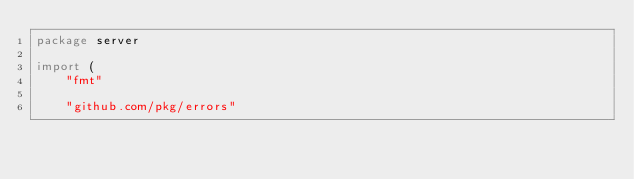Convert code to text. <code><loc_0><loc_0><loc_500><loc_500><_Go_>package server

import (
	"fmt"

	"github.com/pkg/errors"</code> 